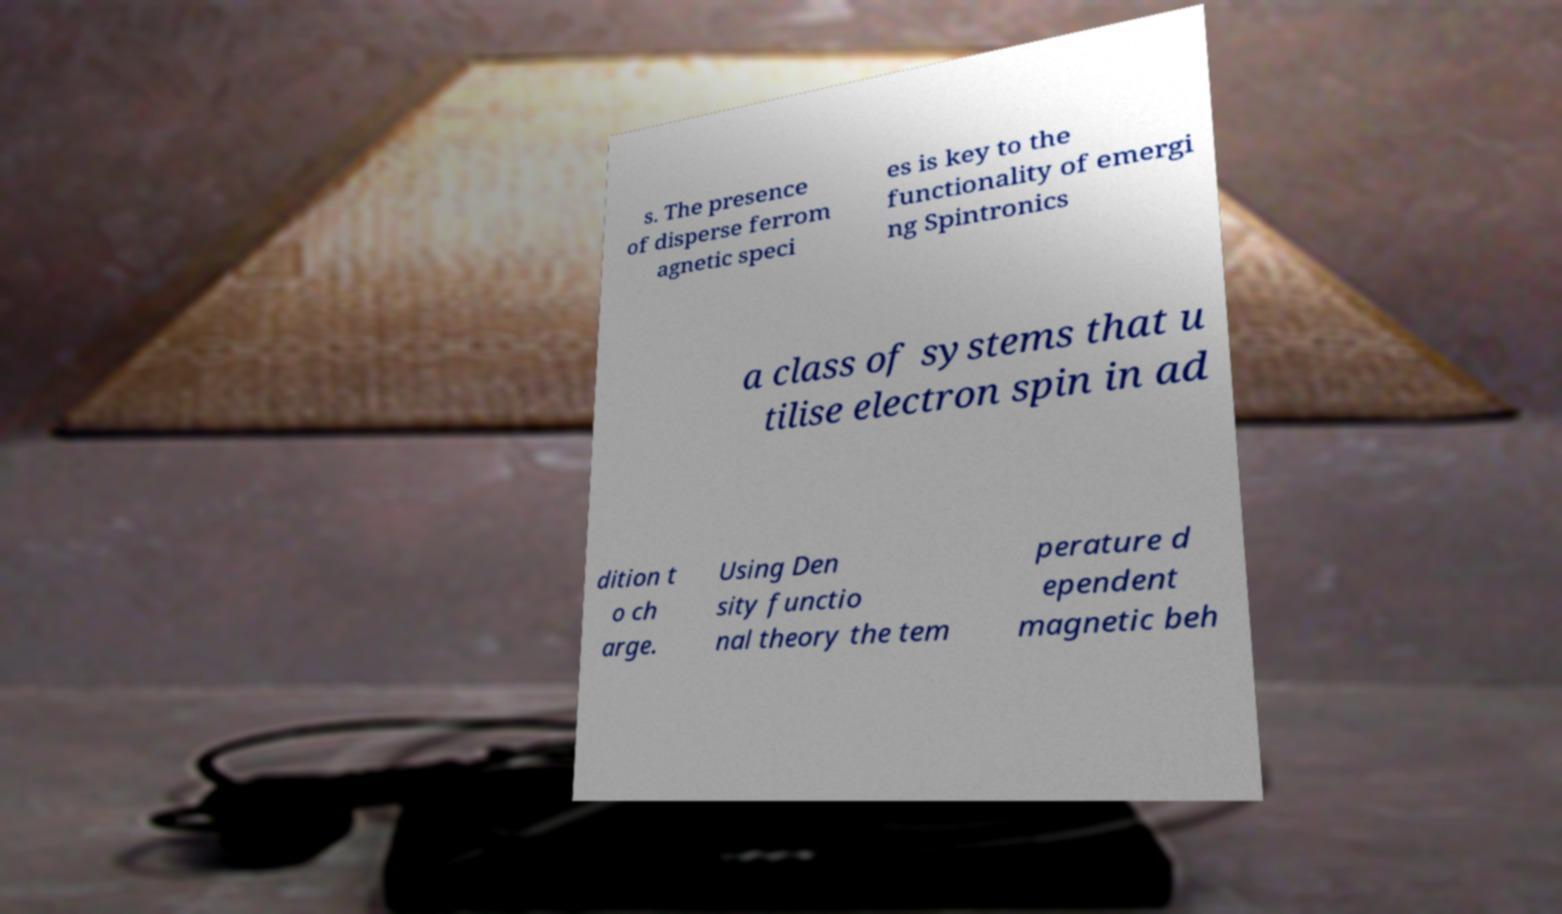I need the written content from this picture converted into text. Can you do that? s. The presence of disperse ferrom agnetic speci es is key to the functionality of emergi ng Spintronics a class of systems that u tilise electron spin in ad dition t o ch arge. Using Den sity functio nal theory the tem perature d ependent magnetic beh 